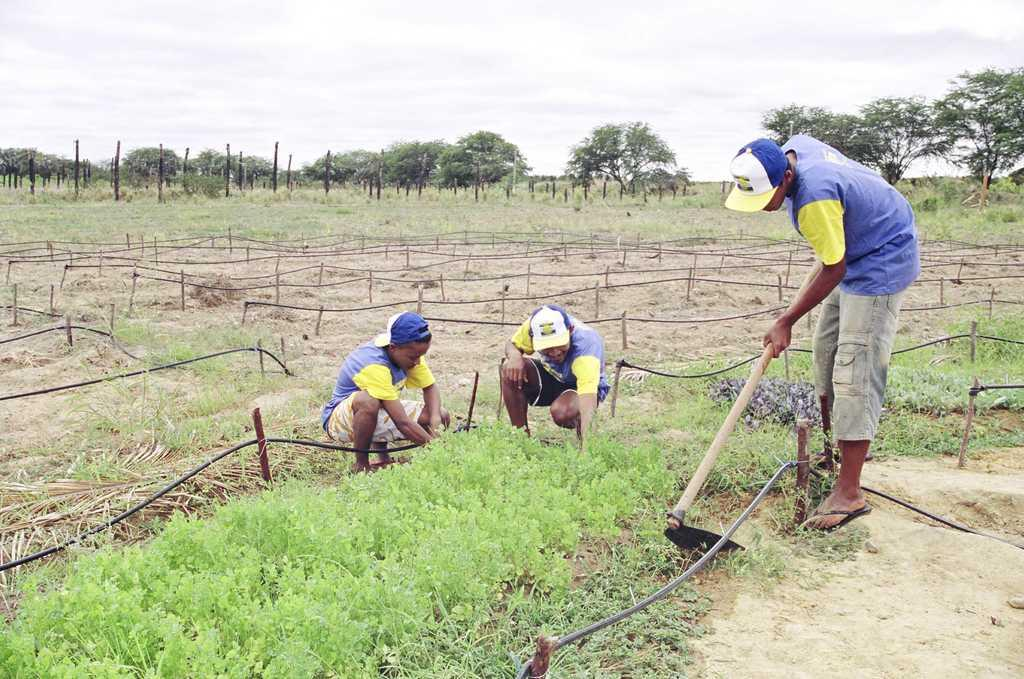How many people are in the image? There are three persons in the image. What is one of the persons doing in the image? One of the persons is holding an object. What type of objects can be seen in the image? There are sticks, pipes, and poles in the image. What type of vegetation is present in the image? There are plants, grass, and trees in the image. What part of the natural environment is visible in the image? The sky is visible in the image. Can you see a turkey walking near the stream in the image? There is no turkey or stream present in the image. 